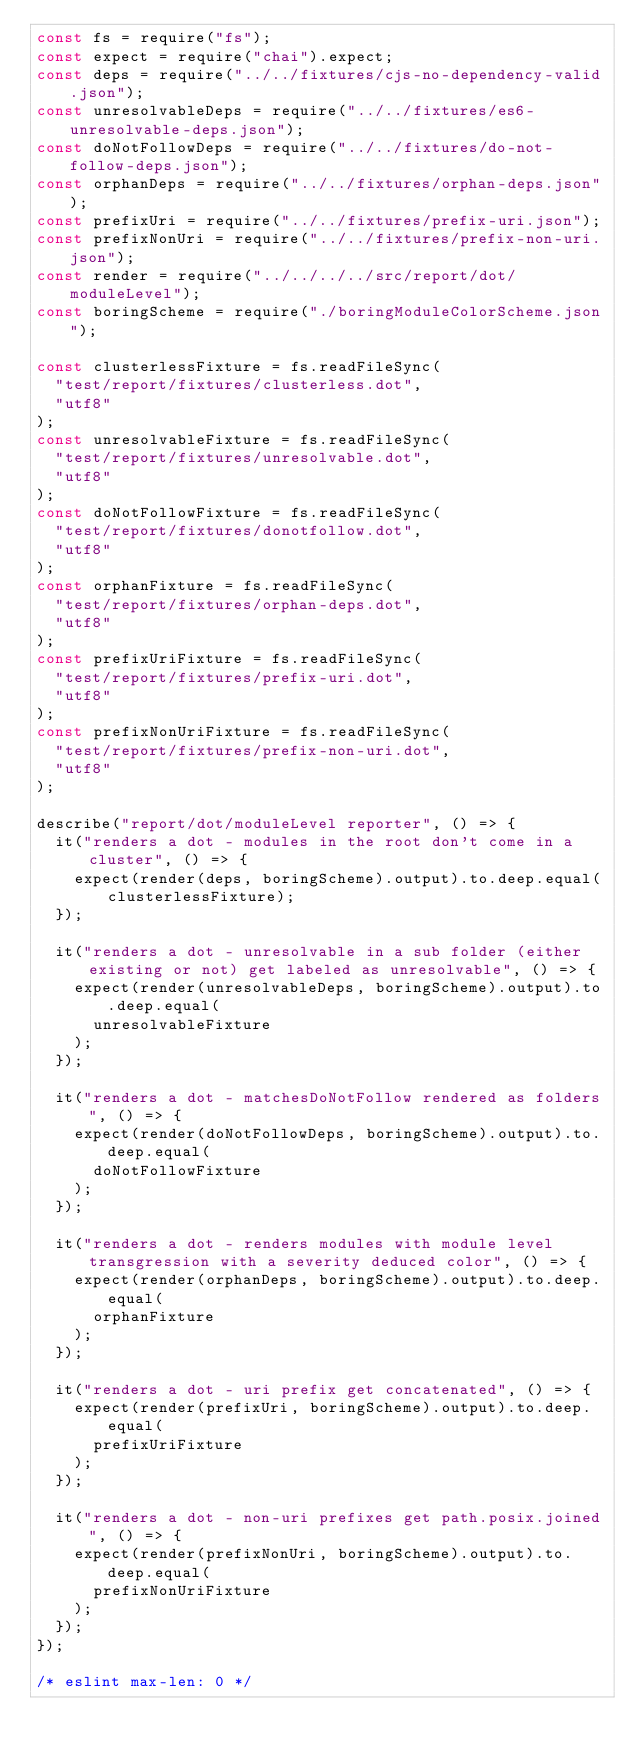Convert code to text. <code><loc_0><loc_0><loc_500><loc_500><_JavaScript_>const fs = require("fs");
const expect = require("chai").expect;
const deps = require("../../fixtures/cjs-no-dependency-valid.json");
const unresolvableDeps = require("../../fixtures/es6-unresolvable-deps.json");
const doNotFollowDeps = require("../../fixtures/do-not-follow-deps.json");
const orphanDeps = require("../../fixtures/orphan-deps.json");
const prefixUri = require("../../fixtures/prefix-uri.json");
const prefixNonUri = require("../../fixtures/prefix-non-uri.json");
const render = require("../../../../src/report/dot/moduleLevel");
const boringScheme = require("./boringModuleColorScheme.json");

const clusterlessFixture = fs.readFileSync(
  "test/report/fixtures/clusterless.dot",
  "utf8"
);
const unresolvableFixture = fs.readFileSync(
  "test/report/fixtures/unresolvable.dot",
  "utf8"
);
const doNotFollowFixture = fs.readFileSync(
  "test/report/fixtures/donotfollow.dot",
  "utf8"
);
const orphanFixture = fs.readFileSync(
  "test/report/fixtures/orphan-deps.dot",
  "utf8"
);
const prefixUriFixture = fs.readFileSync(
  "test/report/fixtures/prefix-uri.dot",
  "utf8"
);
const prefixNonUriFixture = fs.readFileSync(
  "test/report/fixtures/prefix-non-uri.dot",
  "utf8"
);

describe("report/dot/moduleLevel reporter", () => {
  it("renders a dot - modules in the root don't come in a cluster", () => {
    expect(render(deps, boringScheme).output).to.deep.equal(clusterlessFixture);
  });

  it("renders a dot - unresolvable in a sub folder (either existing or not) get labeled as unresolvable", () => {
    expect(render(unresolvableDeps, boringScheme).output).to.deep.equal(
      unresolvableFixture
    );
  });

  it("renders a dot - matchesDoNotFollow rendered as folders", () => {
    expect(render(doNotFollowDeps, boringScheme).output).to.deep.equal(
      doNotFollowFixture
    );
  });

  it("renders a dot - renders modules with module level transgression with a severity deduced color", () => {
    expect(render(orphanDeps, boringScheme).output).to.deep.equal(
      orphanFixture
    );
  });

  it("renders a dot - uri prefix get concatenated", () => {
    expect(render(prefixUri, boringScheme).output).to.deep.equal(
      prefixUriFixture
    );
  });

  it("renders a dot - non-uri prefixes get path.posix.joined", () => {
    expect(render(prefixNonUri, boringScheme).output).to.deep.equal(
      prefixNonUriFixture
    );
  });
});

/* eslint max-len: 0 */
</code> 